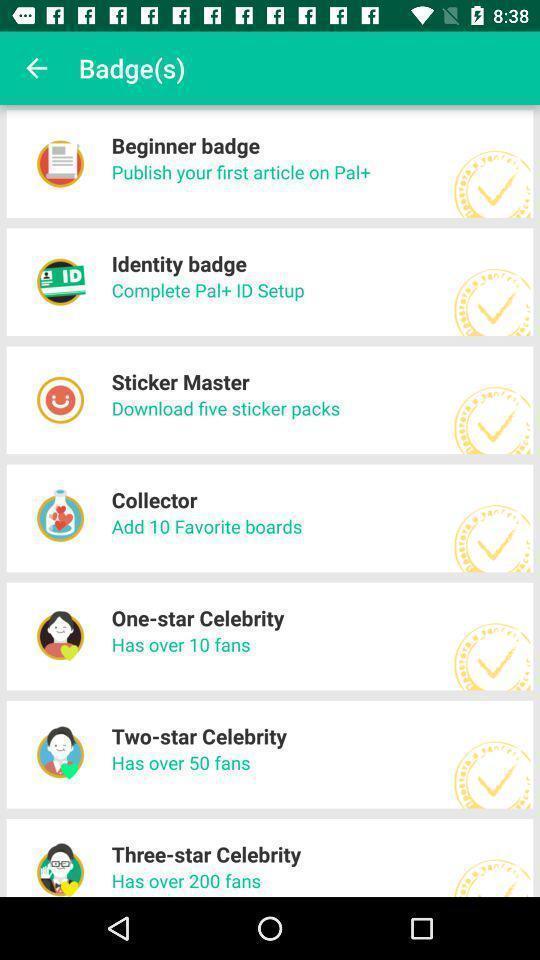Describe the key features of this screenshot. Screen shows list of badges. 